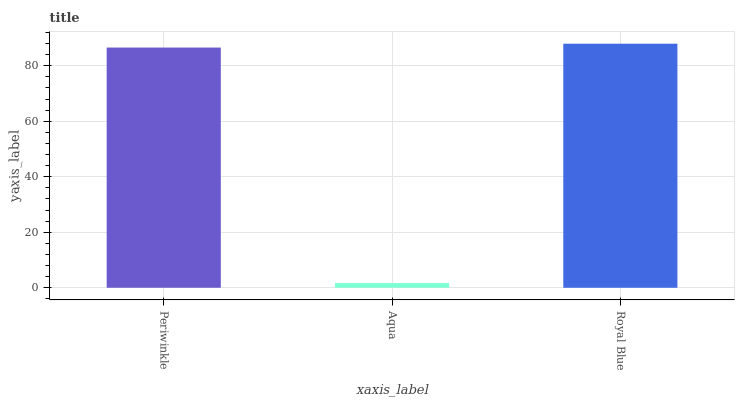Is Aqua the minimum?
Answer yes or no. Yes. Is Royal Blue the maximum?
Answer yes or no. Yes. Is Royal Blue the minimum?
Answer yes or no. No. Is Aqua the maximum?
Answer yes or no. No. Is Royal Blue greater than Aqua?
Answer yes or no. Yes. Is Aqua less than Royal Blue?
Answer yes or no. Yes. Is Aqua greater than Royal Blue?
Answer yes or no. No. Is Royal Blue less than Aqua?
Answer yes or no. No. Is Periwinkle the high median?
Answer yes or no. Yes. Is Periwinkle the low median?
Answer yes or no. Yes. Is Royal Blue the high median?
Answer yes or no. No. Is Royal Blue the low median?
Answer yes or no. No. 